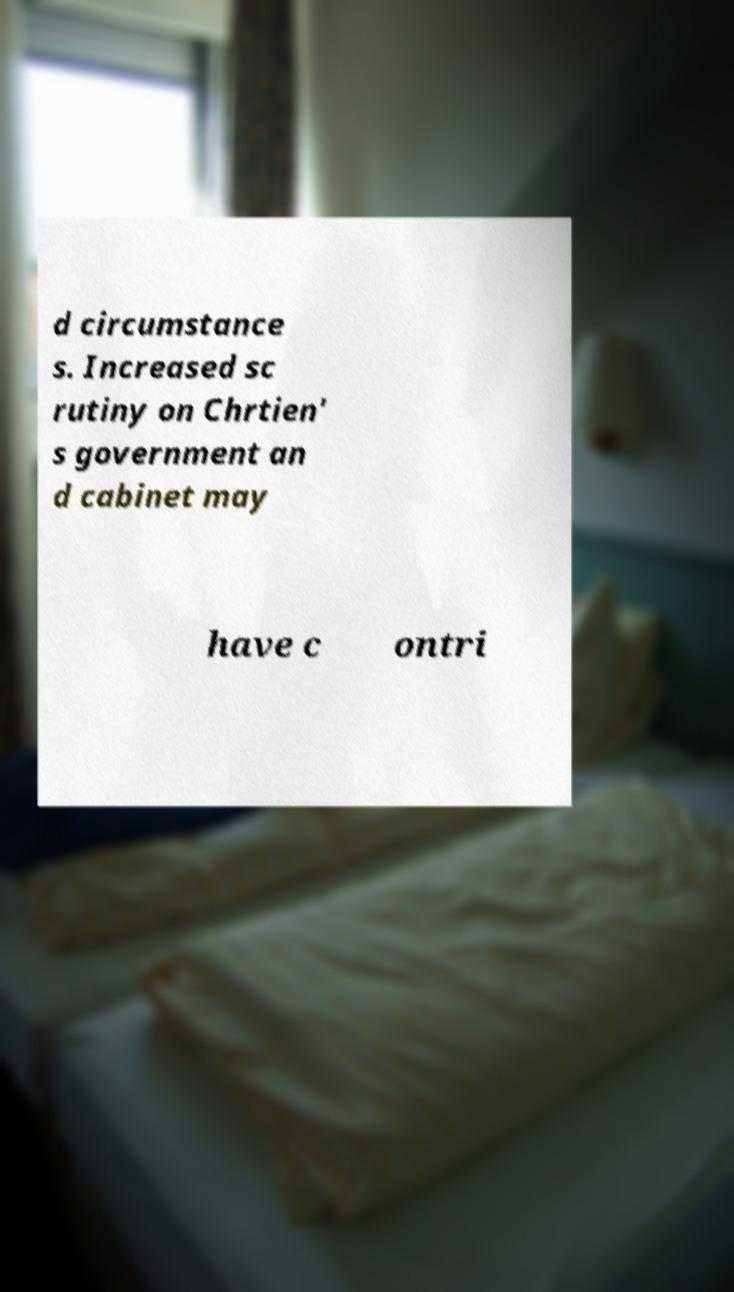What messages or text are displayed in this image? I need them in a readable, typed format. d circumstance s. Increased sc rutiny on Chrtien' s government an d cabinet may have c ontri 